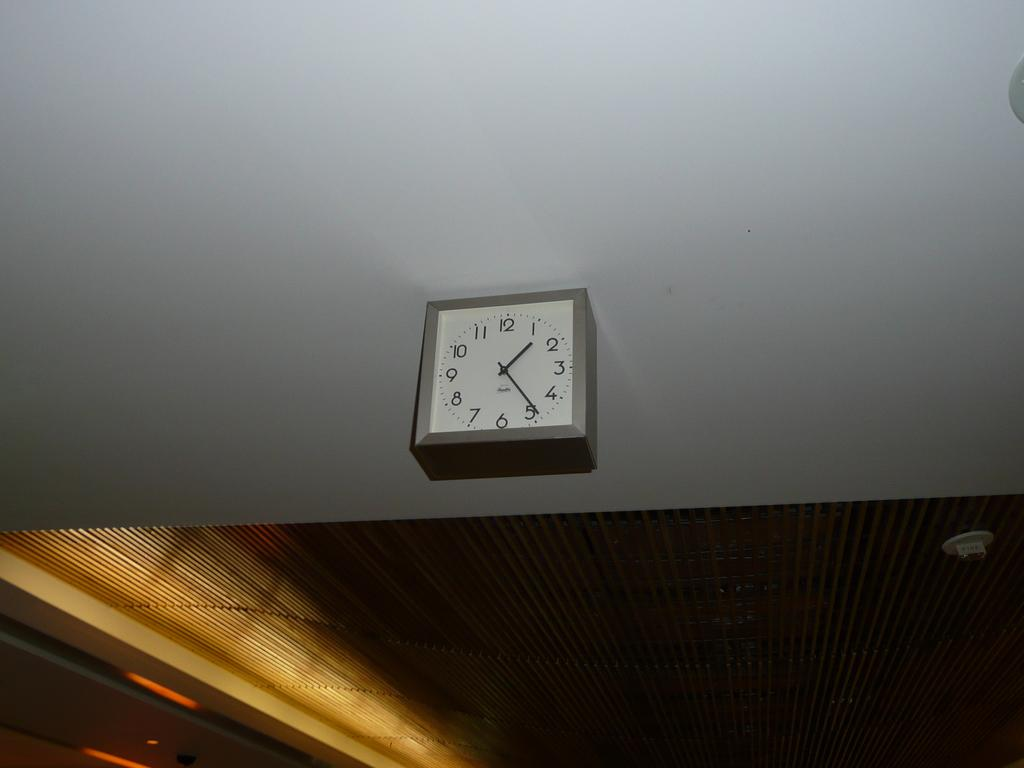<image>
Present a compact description of the photo's key features. A square clock that shows it being 1:24. 